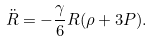Convert formula to latex. <formula><loc_0><loc_0><loc_500><loc_500>\ddot { R } = - { \frac { \gamma } 6 } R ( \rho + 3 P ) .</formula> 